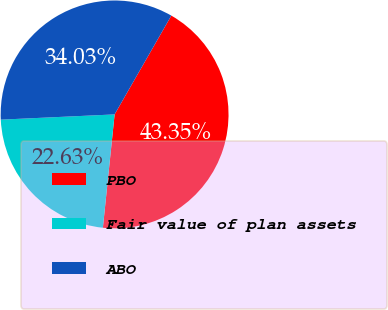Convert chart to OTSL. <chart><loc_0><loc_0><loc_500><loc_500><pie_chart><fcel>PBO<fcel>Fair value of plan assets<fcel>ABO<nl><fcel>43.35%<fcel>22.63%<fcel>34.03%<nl></chart> 